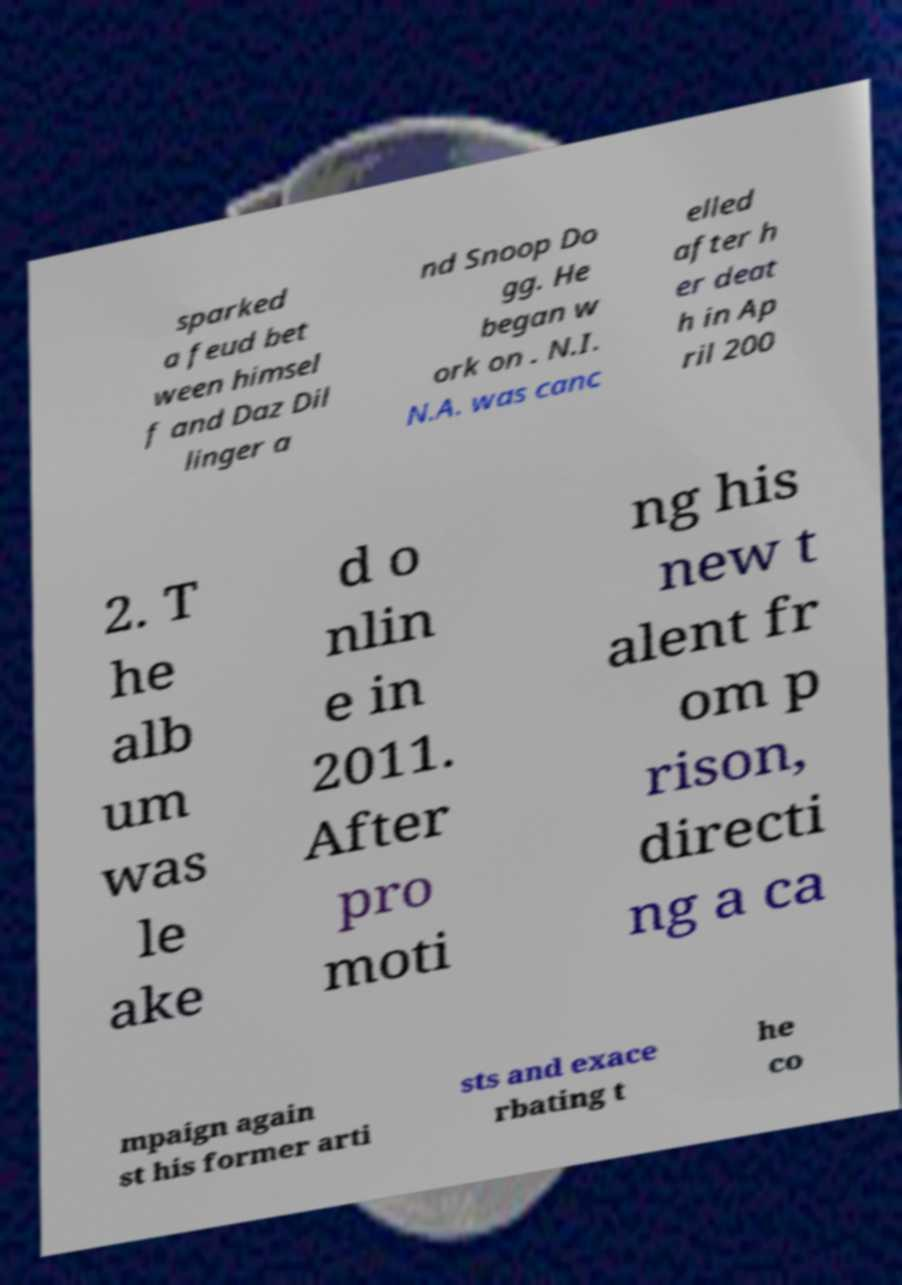Can you read and provide the text displayed in the image?This photo seems to have some interesting text. Can you extract and type it out for me? sparked a feud bet ween himsel f and Daz Dil linger a nd Snoop Do gg. He began w ork on . N.I. N.A. was canc elled after h er deat h in Ap ril 200 2. T he alb um was le ake d o nlin e in 2011. After pro moti ng his new t alent fr om p rison, directi ng a ca mpaign again st his former arti sts and exace rbating t he co 